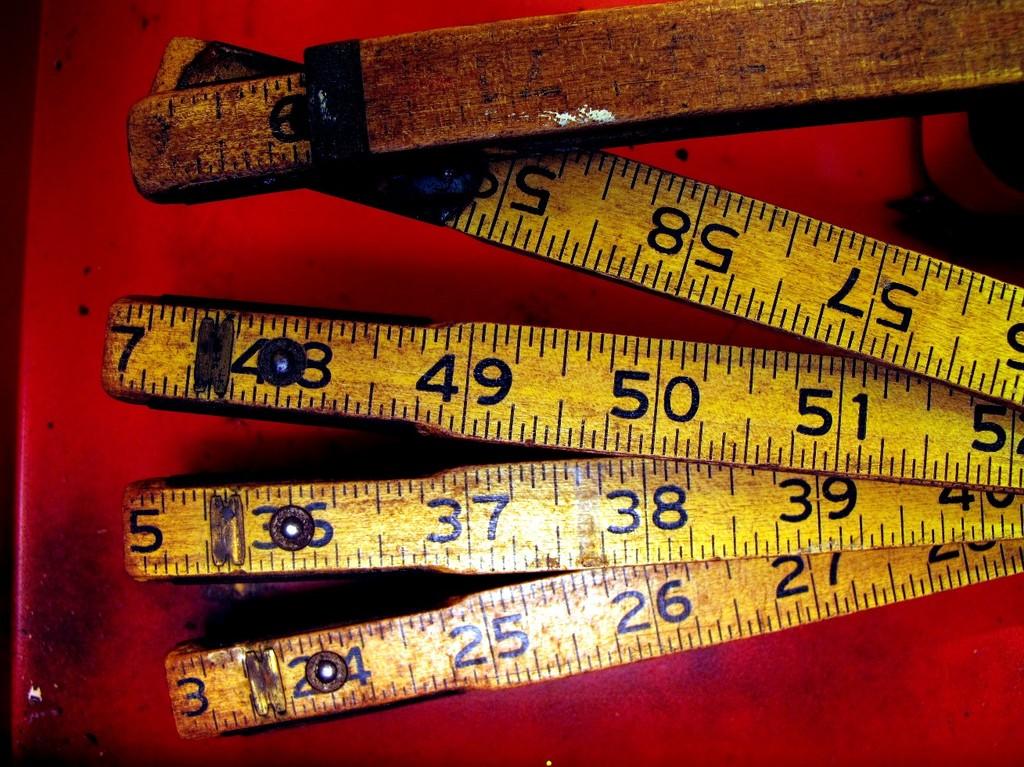What is the smaller number shown?
Provide a succinct answer. 3. What is the largest number shown?
Offer a very short reply. 59. 